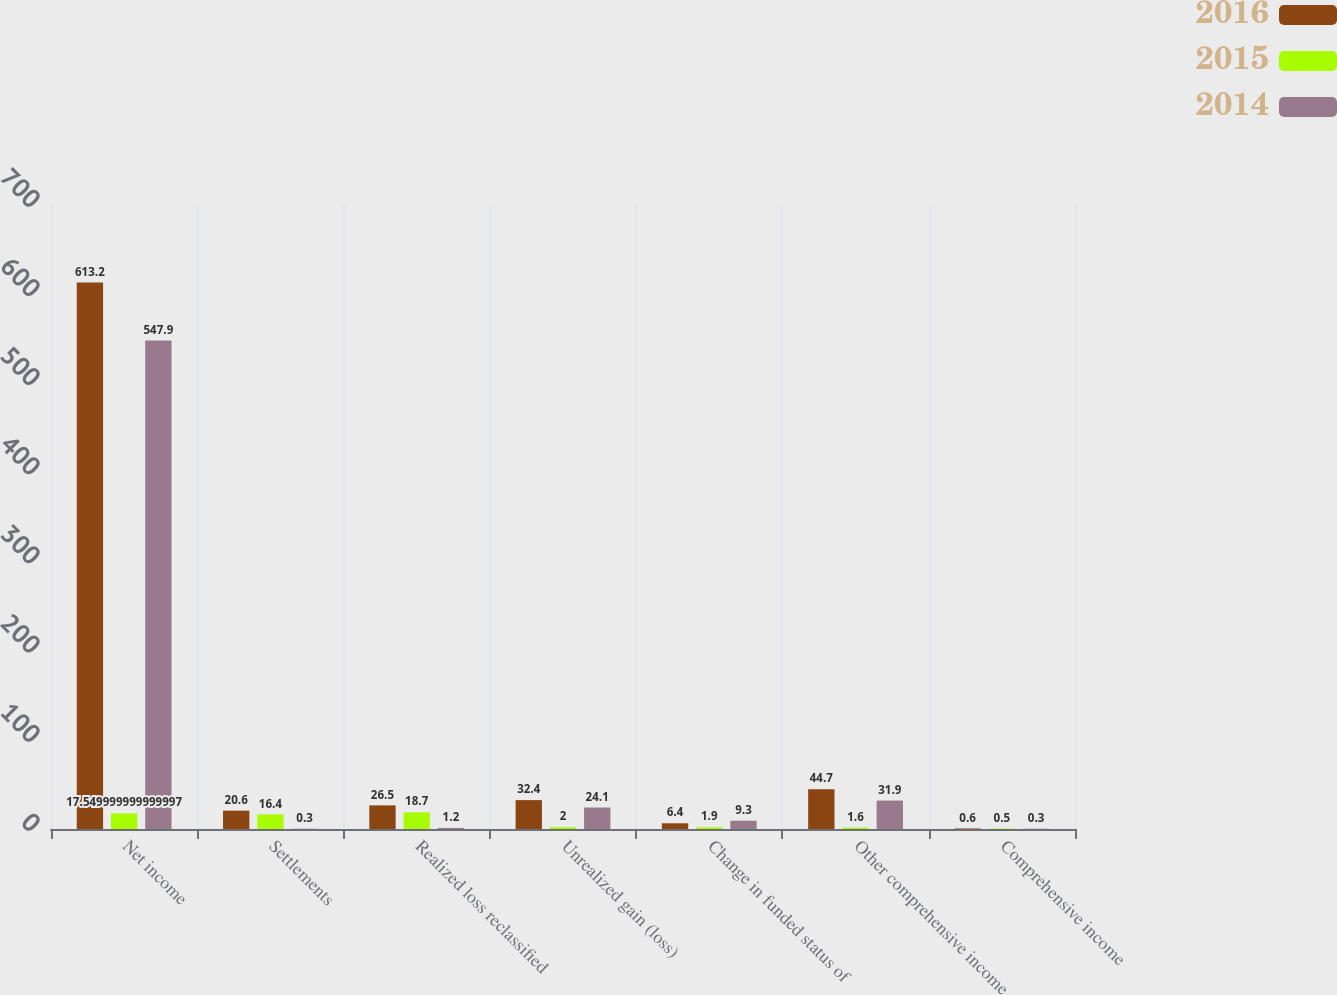<chart> <loc_0><loc_0><loc_500><loc_500><stacked_bar_chart><ecel><fcel>Net income<fcel>Settlements<fcel>Realized loss reclassified<fcel>Unrealized gain (loss)<fcel>Change in funded status of<fcel>Other comprehensive income<fcel>Comprehensive income<nl><fcel>2016<fcel>613.2<fcel>20.6<fcel>26.5<fcel>32.4<fcel>6.4<fcel>44.7<fcel>0.6<nl><fcel>2015<fcel>17.55<fcel>16.4<fcel>18.7<fcel>2<fcel>1.9<fcel>1.6<fcel>0.5<nl><fcel>2014<fcel>547.9<fcel>0.3<fcel>1.2<fcel>24.1<fcel>9.3<fcel>31.9<fcel>0.3<nl></chart> 